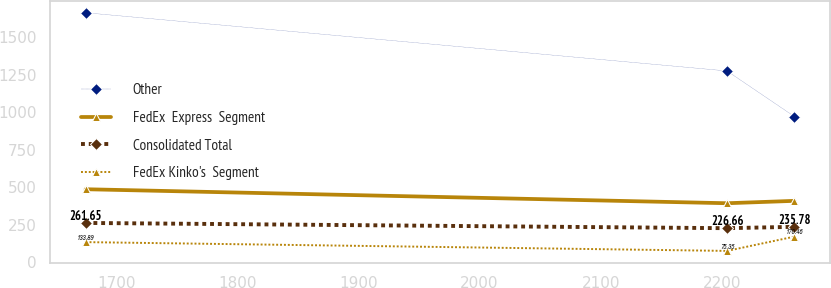Convert chart to OTSL. <chart><loc_0><loc_0><loc_500><loc_500><line_chart><ecel><fcel>Other<fcel>FedEx  Express  Segment<fcel>Consolidated Total<fcel>FedEx Kinko's  Segment<nl><fcel>1674.84<fcel>1661.4<fcel>486.06<fcel>261.65<fcel>133.89<nl><fcel>2204.2<fcel>1273.74<fcel>392.86<fcel>226.66<fcel>75.35<nl><fcel>2259.78<fcel>970.32<fcel>408.65<fcel>235.78<fcel>170.46<nl></chart> 